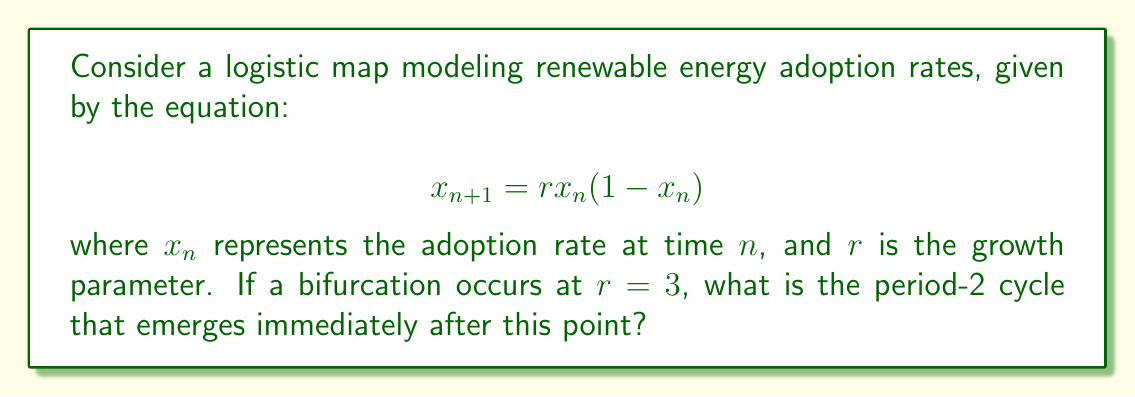Could you help me with this problem? To find the period-2 cycle after the bifurcation at $r = 3$, we follow these steps:

1) The bifurcation occurs when $r > 3$. Let's consider a value slightly larger than 3, say $r = 3.1$.

2) For a period-2 cycle, we need to solve the equation:
   $$x = f(f(x))$$
   where $f(x) = rx(1-x)$

3) Expand this equation:
   $$x = r[rx(1-x)](1-[rx(1-x)])$$

4) Simplify:
   $$x = r^2x(1-x)(1-rx+rx^2)$$

5) Expand further:
   $$x = r^2x - r^2x^2 - r^3x^2 + r^3x^3 + r^3x^3 - r^3x^4$$

6) Rearrange:
   $$r^3x^4 - (2r^3)x^3 + (r^3+r^2)x^2 - r^2x + x = 0$$

7) Substitute $r = 3.1$:
   $$29.791x^4 - 59.582x^3 + 38.75x^2 - 9.61x + 1 = 0$$

8) This equation has four roots. Two of them (0 and 1) correspond to the fixed points. The other two are the points of the period-2 cycle.

9) Solving numerically (using a computer algebra system), we get:
   $x_1 \approx 0.7645$
   $x_2 \approx 0.5579$

10) These two points alternate in the period-2 cycle.
Answer: (0.7645, 0.5579) 